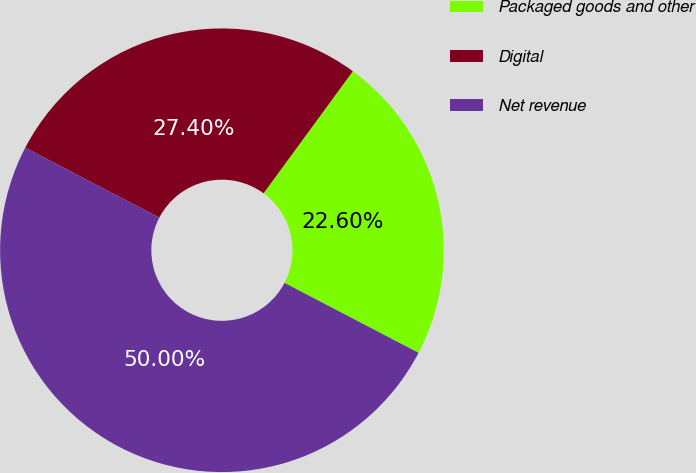<chart> <loc_0><loc_0><loc_500><loc_500><pie_chart><fcel>Packaged goods and other<fcel>Digital<fcel>Net revenue<nl><fcel>22.6%<fcel>27.4%<fcel>50.0%<nl></chart> 